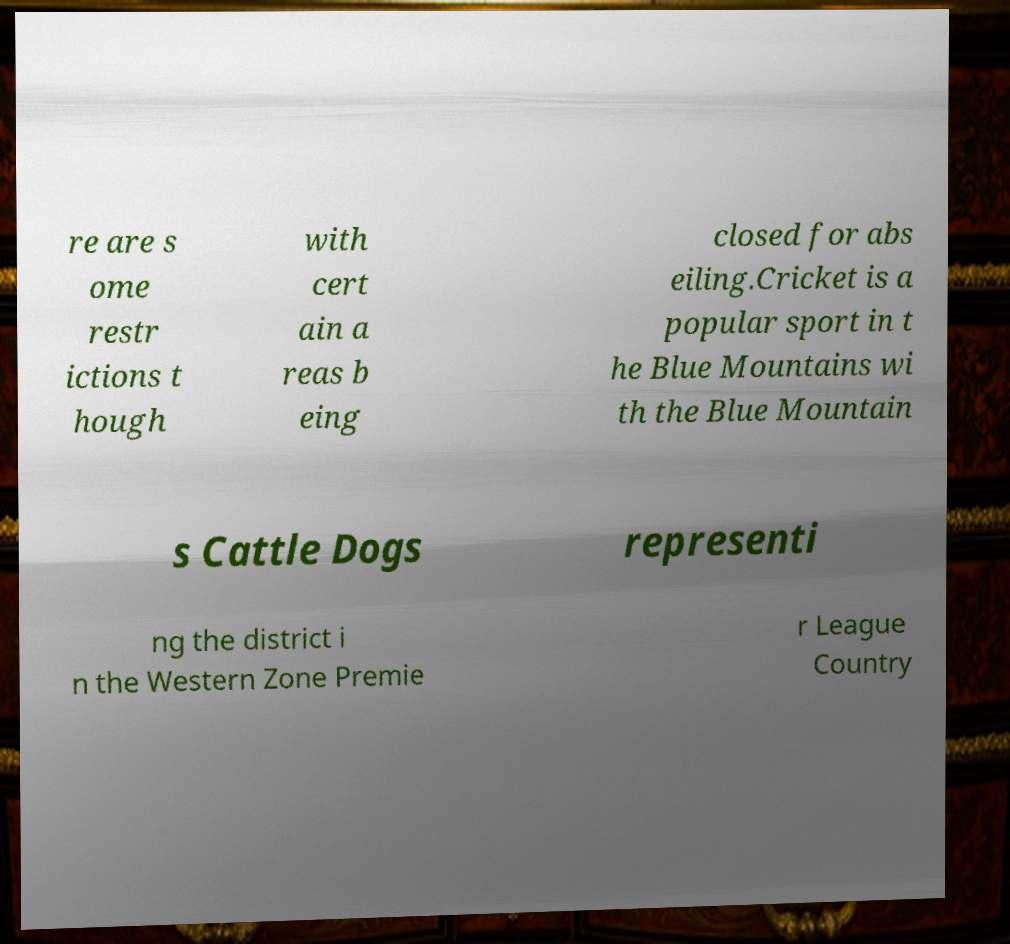Can you read and provide the text displayed in the image?This photo seems to have some interesting text. Can you extract and type it out for me? re are s ome restr ictions t hough with cert ain a reas b eing closed for abs eiling.Cricket is a popular sport in t he Blue Mountains wi th the Blue Mountain s Cattle Dogs representi ng the district i n the Western Zone Premie r League Country 